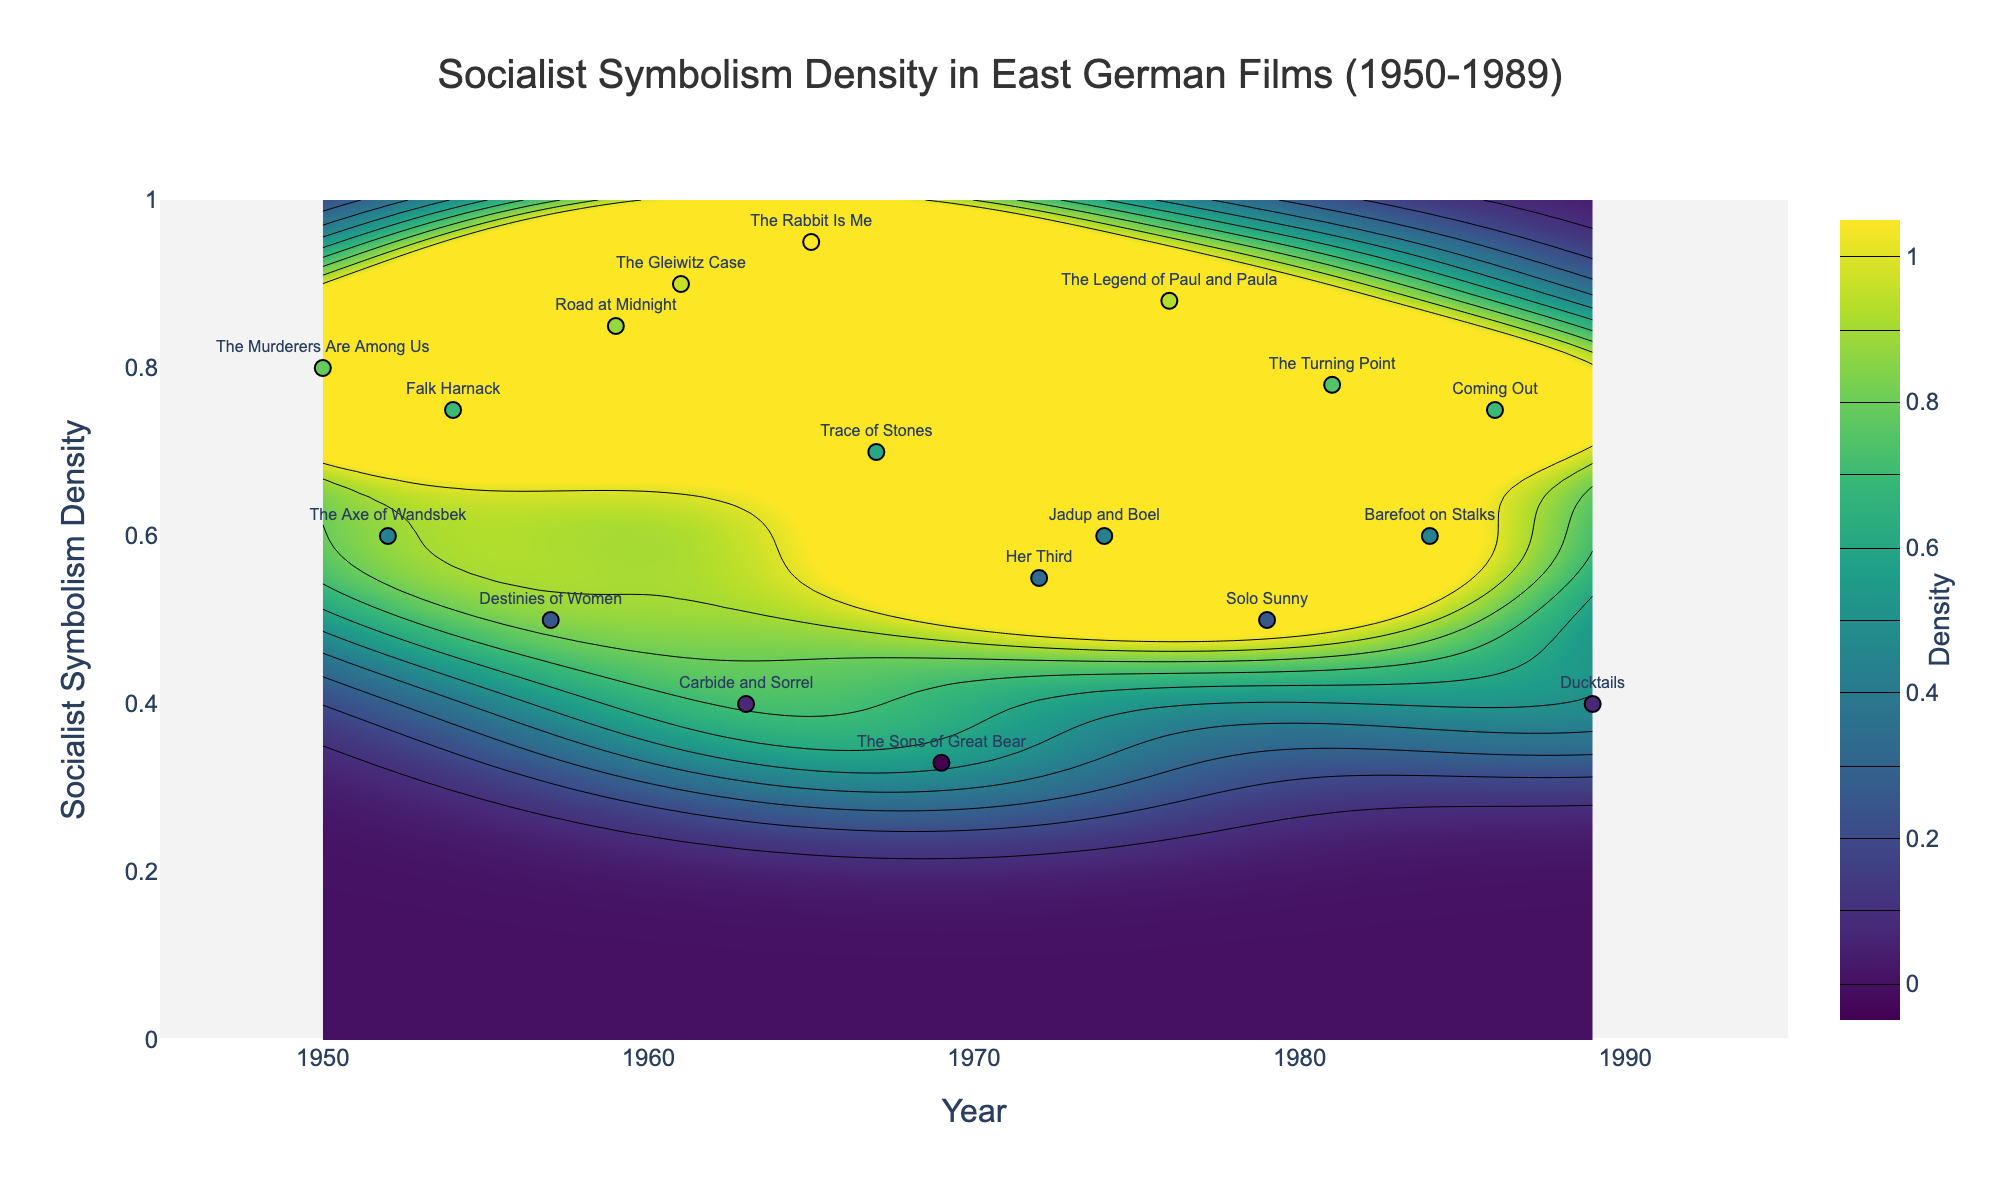what is the range of years displayed on the horizontal axis? The plot's horizontal axis has a title "Year". The ticks on this axis extend from 1945 to 1995. By examining the full span from the minimum to the maximum year, we can determine the range.
Answer: 1945 to 1995 How many films are represented in the plot? The scatter plot overlaid on the contour plot includes individual data points, each corresponding to a different film. Counting the distinct points on the plot reveals the number of films.
Answer: 18 Which year shows the highest density of socialist symbolism? Examining the contour plot, the color intensity indicates density. The year with the highest density corresponds to where the dark/brightest region is located near the year axis. The year 1965 stands out as the highest.
Answer: 1965 what is the average density of socialist symbolism for the films released in the 1970s? First, identify the films released in the 1970s: "Her Third" (0.55), "Jadup and Boel" (0.6), "The Legend of Paul and Paula" (0.88), and "Solo Sunny" (0.5). Sum these densities: 0.55 + 0.6+ 0.88 + 0.5 = 2.53. Divide the total by the number of films (4): 2.53 / 4.
Answer: 0.6325 Which film has the lowest density of socialist symbolism? Look for the lowest y-value among the scatter plot points. “The Sons of Great Bear” released in 1969 with a density of 0.33, represents this minimum value.
Answer: The Sons of Great Bear Is there any film after 1985 with a density greater than 0.7? Examine the scatter plot and identify the points corresponding to years after 1985. "Coming Out" (1986) with a density of 0.75 is the only one matching these criteria.
Answer: Yes Compare the socialist symbolism density of 'The Murderers Are Among Us' and 'The Rabbit Is Me'. Which one is higher? Locate these films in the scatter plot: "The Murderers Are Among Us" (1950, 0.8) and "The Rabbit Is Me" (1965, 0.95). Comparing these densities, 0.95 is greater than 0.8.
Answer: The Rabbit Is Me Identify any periods of time with a noticeable drop in socialist symbolism density. Observing the contour plot’s color transitions, there appears to be a notable drop in density around the early 1960s. This is deduced from the change from higher (darker) to lower (lighter) density colors in that period.
Answer: Early 1960s Are there any patterns or trends in socialist symbolism density over time? The contour plot's overall color gradient suggests that socialist symbolism density fluctuated over time. It appears to peak around 1965, decreases towards the late 1960s and 1970s, then shows some resurgence in the late 1970s and early 1980s. This pattern indicates cycles of high and low density across the years.
Answer: Fluctuating cycles with peaks and troughs How does the symbolism density of 'Destinies of Women' (1957) compare to the average density of films in the 1980s? First, note the "Destinies of Women" density: 0.5. Then, identify 1980s films: "Solo Sunny" (0.5), "The Turning Point" (0.78), "Barefoot on Stalks" (0.6), "Coming Out" (0.75), "Ducktails" (0.4). Average density of these 1980s films: (0.5+0.78+0.6+0.75+0.4) / 5 = 3.03 / 5. Comparing, 0.5 is less than 0.606.
Answer: Less 